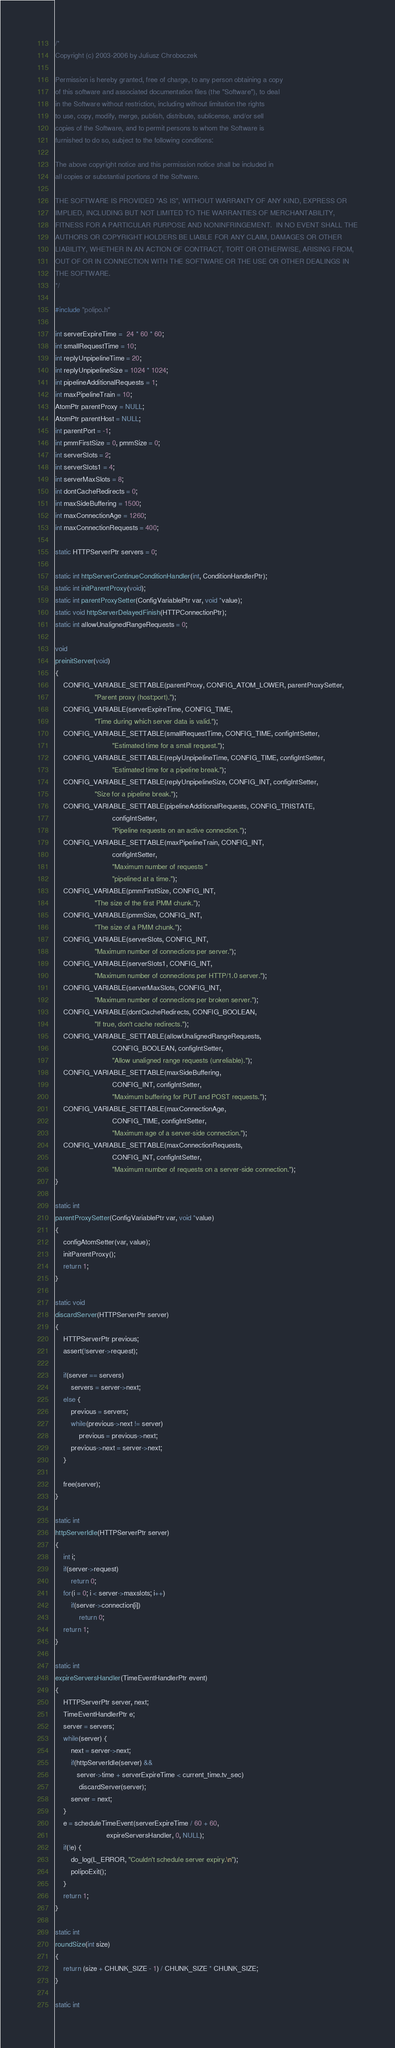<code> <loc_0><loc_0><loc_500><loc_500><_C_>/*
Copyright (c) 2003-2006 by Juliusz Chroboczek

Permission is hereby granted, free of charge, to any person obtaining a copy
of this software and associated documentation files (the "Software"), to deal
in the Software without restriction, including without limitation the rights
to use, copy, modify, merge, publish, distribute, sublicense, and/or sell
copies of the Software, and to permit persons to whom the Software is
furnished to do so, subject to the following conditions:

The above copyright notice and this permission notice shall be included in
all copies or substantial portions of the Software.

THE SOFTWARE IS PROVIDED "AS IS", WITHOUT WARRANTY OF ANY KIND, EXPRESS OR
IMPLIED, INCLUDING BUT NOT LIMITED TO THE WARRANTIES OF MERCHANTABILITY,
FITNESS FOR A PARTICULAR PURPOSE AND NONINFRINGEMENT.  IN NO EVENT SHALL THE
AUTHORS OR COPYRIGHT HOLDERS BE LIABLE FOR ANY CLAIM, DAMAGES OR OTHER
LIABILITY, WHETHER IN AN ACTION OF CONTRACT, TORT OR OTHERWISE, ARISING FROM,
OUT OF OR IN CONNECTION WITH THE SOFTWARE OR THE USE OR OTHER DEALINGS IN
THE SOFTWARE.
*/

#include "polipo.h"

int serverExpireTime =  24 * 60 * 60;
int smallRequestTime = 10;
int replyUnpipelineTime = 20;
int replyUnpipelineSize = 1024 * 1024;
int pipelineAdditionalRequests = 1;
int maxPipelineTrain = 10;
AtomPtr parentProxy = NULL;
AtomPtr parentHost = NULL;
int parentPort = -1;
int pmmFirstSize = 0, pmmSize = 0;
int serverSlots = 2;
int serverSlots1 = 4;
int serverMaxSlots = 8;
int dontCacheRedirects = 0;
int maxSideBuffering = 1500;
int maxConnectionAge = 1260;
int maxConnectionRequests = 400;

static HTTPServerPtr servers = 0;

static int httpServerContinueConditionHandler(int, ConditionHandlerPtr);
static int initParentProxy(void);
static int parentProxySetter(ConfigVariablePtr var, void *value);
static void httpServerDelayedFinish(HTTPConnectionPtr);
static int allowUnalignedRangeRequests = 0;

void
preinitServer(void)
{
    CONFIG_VARIABLE_SETTABLE(parentProxy, CONFIG_ATOM_LOWER, parentProxySetter,
                    "Parent proxy (host:port).");
    CONFIG_VARIABLE(serverExpireTime, CONFIG_TIME,
                    "Time during which server data is valid.");
    CONFIG_VARIABLE_SETTABLE(smallRequestTime, CONFIG_TIME, configIntSetter,
                             "Estimated time for a small request.");
    CONFIG_VARIABLE_SETTABLE(replyUnpipelineTime, CONFIG_TIME, configIntSetter,
                             "Estimated time for a pipeline break.");
    CONFIG_VARIABLE_SETTABLE(replyUnpipelineSize, CONFIG_INT, configIntSetter,
                    "Size for a pipeline break.");
    CONFIG_VARIABLE_SETTABLE(pipelineAdditionalRequests, CONFIG_TRISTATE,
                             configIntSetter,
                             "Pipeline requests on an active connection.");
    CONFIG_VARIABLE_SETTABLE(maxPipelineTrain, CONFIG_INT,
                             configIntSetter,
                             "Maximum number of requests "
                             "pipelined at a time.");
    CONFIG_VARIABLE(pmmFirstSize, CONFIG_INT,
                    "The size of the first PMM chunk.");
    CONFIG_VARIABLE(pmmSize, CONFIG_INT,
                    "The size of a PMM chunk.");
    CONFIG_VARIABLE(serverSlots, CONFIG_INT,
                    "Maximum number of connections per server.");
    CONFIG_VARIABLE(serverSlots1, CONFIG_INT,
                    "Maximum number of connections per HTTP/1.0 server.");
    CONFIG_VARIABLE(serverMaxSlots, CONFIG_INT,
                    "Maximum number of connections per broken server.");
    CONFIG_VARIABLE(dontCacheRedirects, CONFIG_BOOLEAN,
                    "If true, don't cache redirects.");
    CONFIG_VARIABLE_SETTABLE(allowUnalignedRangeRequests,
                             CONFIG_BOOLEAN, configIntSetter,
                             "Allow unaligned range requests (unreliable).");
    CONFIG_VARIABLE_SETTABLE(maxSideBuffering,
                             CONFIG_INT, configIntSetter,
                             "Maximum buffering for PUT and POST requests.");
    CONFIG_VARIABLE_SETTABLE(maxConnectionAge,
                             CONFIG_TIME, configIntSetter,
                             "Maximum age of a server-side connection.");
    CONFIG_VARIABLE_SETTABLE(maxConnectionRequests,
                             CONFIG_INT, configIntSetter,
                             "Maximum number of requests on a server-side connection.");
}

static int
parentProxySetter(ConfigVariablePtr var, void *value)
{
    configAtomSetter(var, value);
    initParentProxy();
    return 1;
}

static void
discardServer(HTTPServerPtr server)
{
    HTTPServerPtr previous;
    assert(!server->request);

    if(server == servers)
        servers = server->next;
    else {
        previous = servers;
        while(previous->next != server)
            previous = previous->next;
        previous->next = server->next;
    }

    free(server);
}

static int
httpServerIdle(HTTPServerPtr server)
{
    int i;
    if(server->request) 
        return 0;
    for(i = 0; i < server->maxslots; i++)
        if(server->connection[i])
            return 0;
    return 1;
}

static int
expireServersHandler(TimeEventHandlerPtr event)
{
    HTTPServerPtr server, next;
    TimeEventHandlerPtr e;
    server = servers;
    while(server) {
        next = server->next;
        if(httpServerIdle(server) &&
           server->time + serverExpireTime < current_time.tv_sec)
            discardServer(server);
        server = next;
    }
    e = scheduleTimeEvent(serverExpireTime / 60 + 60, 
                          expireServersHandler, 0, NULL);
    if(!e) {
        do_log(L_ERROR, "Couldn't schedule server expiry.\n");
        polipoExit();
    }
    return 1;
}

static int
roundSize(int size)
{
    return (size + CHUNK_SIZE - 1) / CHUNK_SIZE * CHUNK_SIZE;
}

static int</code> 